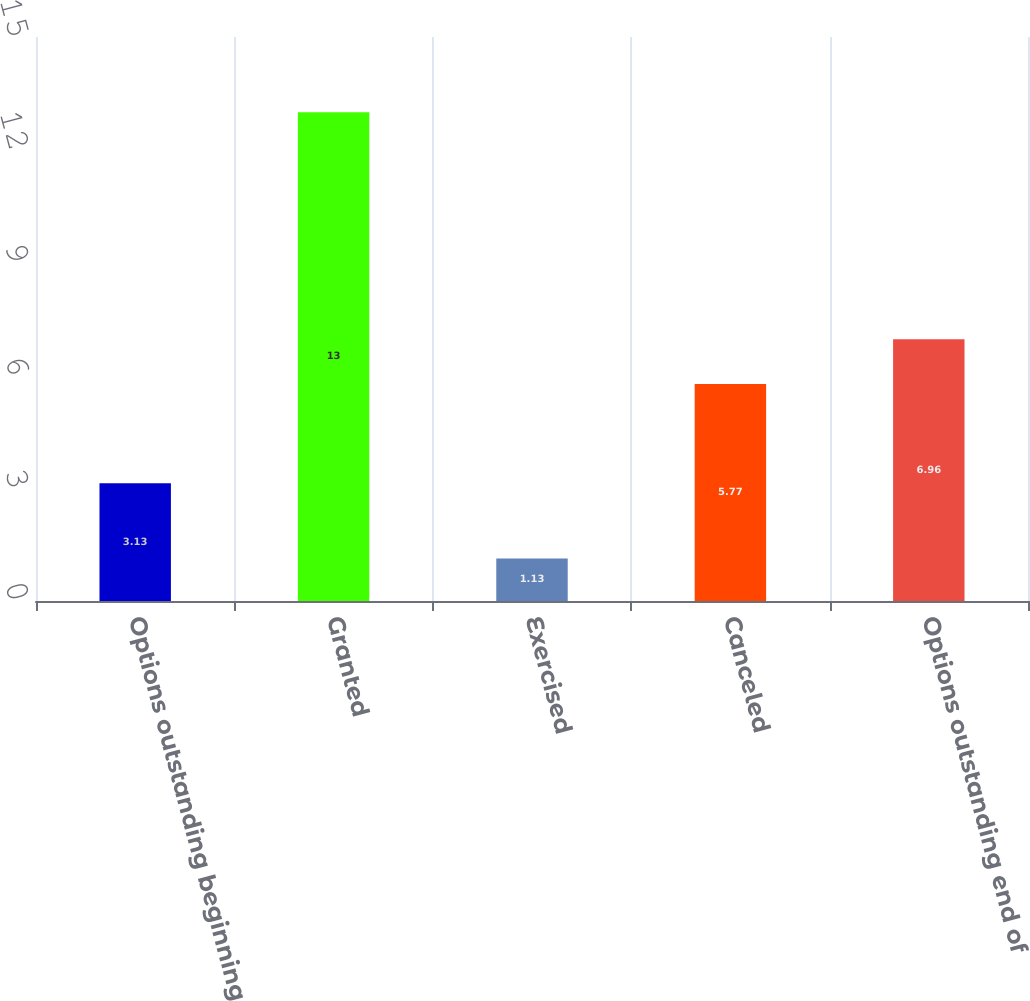Convert chart to OTSL. <chart><loc_0><loc_0><loc_500><loc_500><bar_chart><fcel>Options outstanding beginning<fcel>Granted<fcel>Exercised<fcel>Canceled<fcel>Options outstanding end of<nl><fcel>3.13<fcel>13<fcel>1.13<fcel>5.77<fcel>6.96<nl></chart> 